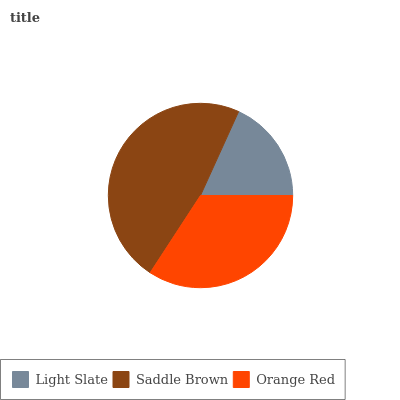Is Light Slate the minimum?
Answer yes or no. Yes. Is Saddle Brown the maximum?
Answer yes or no. Yes. Is Orange Red the minimum?
Answer yes or no. No. Is Orange Red the maximum?
Answer yes or no. No. Is Saddle Brown greater than Orange Red?
Answer yes or no. Yes. Is Orange Red less than Saddle Brown?
Answer yes or no. Yes. Is Orange Red greater than Saddle Brown?
Answer yes or no. No. Is Saddle Brown less than Orange Red?
Answer yes or no. No. Is Orange Red the high median?
Answer yes or no. Yes. Is Orange Red the low median?
Answer yes or no. Yes. Is Light Slate the high median?
Answer yes or no. No. Is Light Slate the low median?
Answer yes or no. No. 